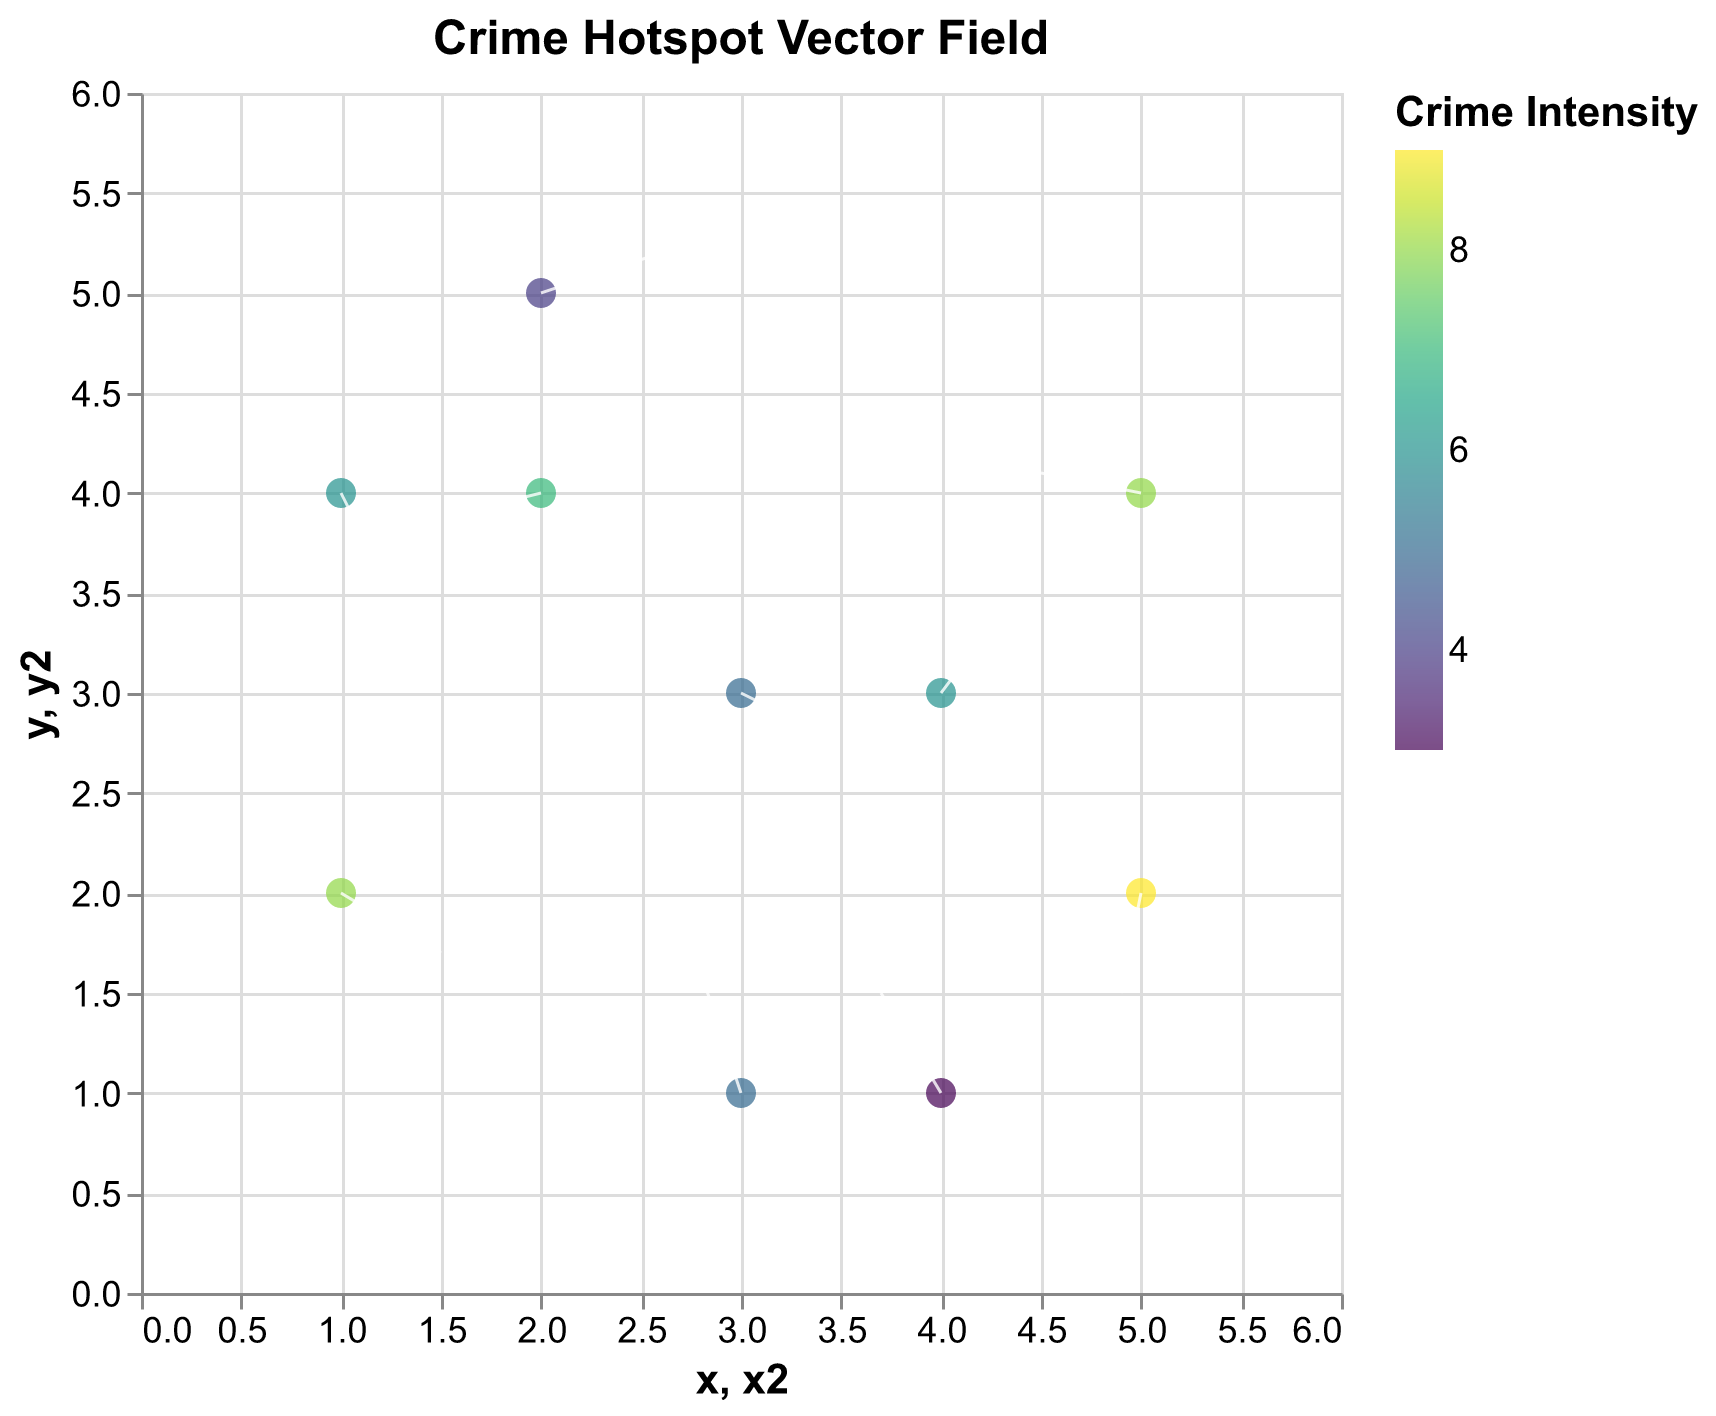How many data points are shown in the figure? Count the number of points in the figure. There are 10 points given in the data.
Answer: 10 What is the title of the figure? The title is usually displayed at the top of the figure.
Answer: Crime Hotspot Vector Field Which data point has the highest crime intensity? Identify the point with the highest intensity value in the legend. The data point at (5, 2) has the highest intensity of 9.
Answer: (5, 2) Where do you see the largest vector magnitude in the figure? The largest vector magnitude can be deduced by visually identifying the longest vector from its root to tip. The vector starting at (2, 5) heading towards (2.6, 5.2) seems the longest.
Answer: (2, 5) What direction is the vector at (3,1) pointing? Determine the direction based on the vector's orientation. The vector at (3,1) points upwards to the right as per coordinates (-0.2, 0.6).
Answer: Upwards to the right Which vector has the smallest intensity value and what is it? Identify the vector with the lowest intensity value in the legend. The vector at (4, 1) has the lowest intensity value of 3.
Answer: (4, 1), 3 What relationship exists between crime intensity and vector length? Identify if intense crime hotspots correlate with longer vectors. Vectors with higher intensities seem to be longer, as observed with the highest intensity at (5, 2).
Answer: Positive relationship Which quadrant has the most vectors pointing downwards? Analyze the vectors' orientation in each quadrant. The first quadrant, particularly around points (1,2), (1,4), and (5,2) shows most vectors pointing down.
Answer: First quadrant In which direction is the vector at (2, 4) pointing? Determine the direction based on the vector's orientation. The vector at (2,4) points slightly downwards to the left as per coordinates (-0.4, -0.1).
Answer: Downwards to the left Which point has the most vectors pointing towards it? Look for vectors' directions converging to a common point. Multiple vectors point towards (3,3), from (4,3) and (2, 4).
Answer: (3, 3) 